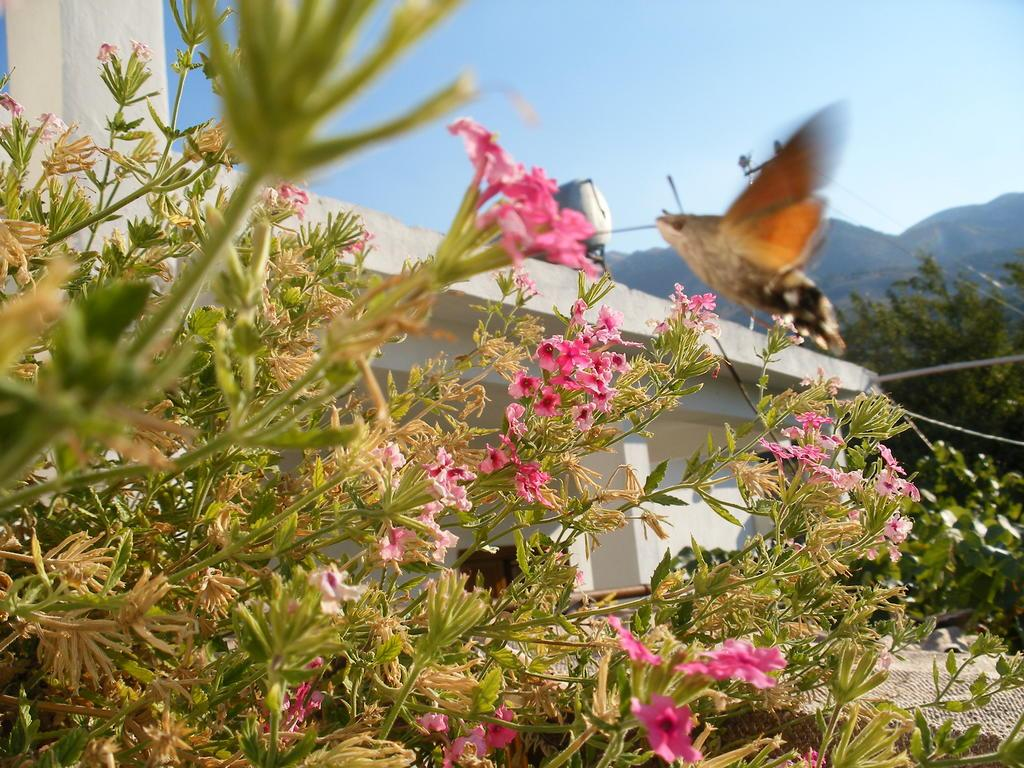What types of living organisms can be seen in the middle of the image? The image contains plants and flowers in the middle. What color are the flowers? The flowers are pink. What structure is located in the middle of the image? There is a building in the middle of the image. What type of vegetation is on the right side of the image? There are trees on the right side of the image. What is visible at the top of the image? The sky is visible at the top of the image. What type of list can be seen hanging from the trees on the right side of the image? There is no list present in the image; it features plants, flowers, a building, trees, and the sky. Is there a kite flying in the sky in the image? No, there is no kite visible in the image; only the sky is visible at the top. 